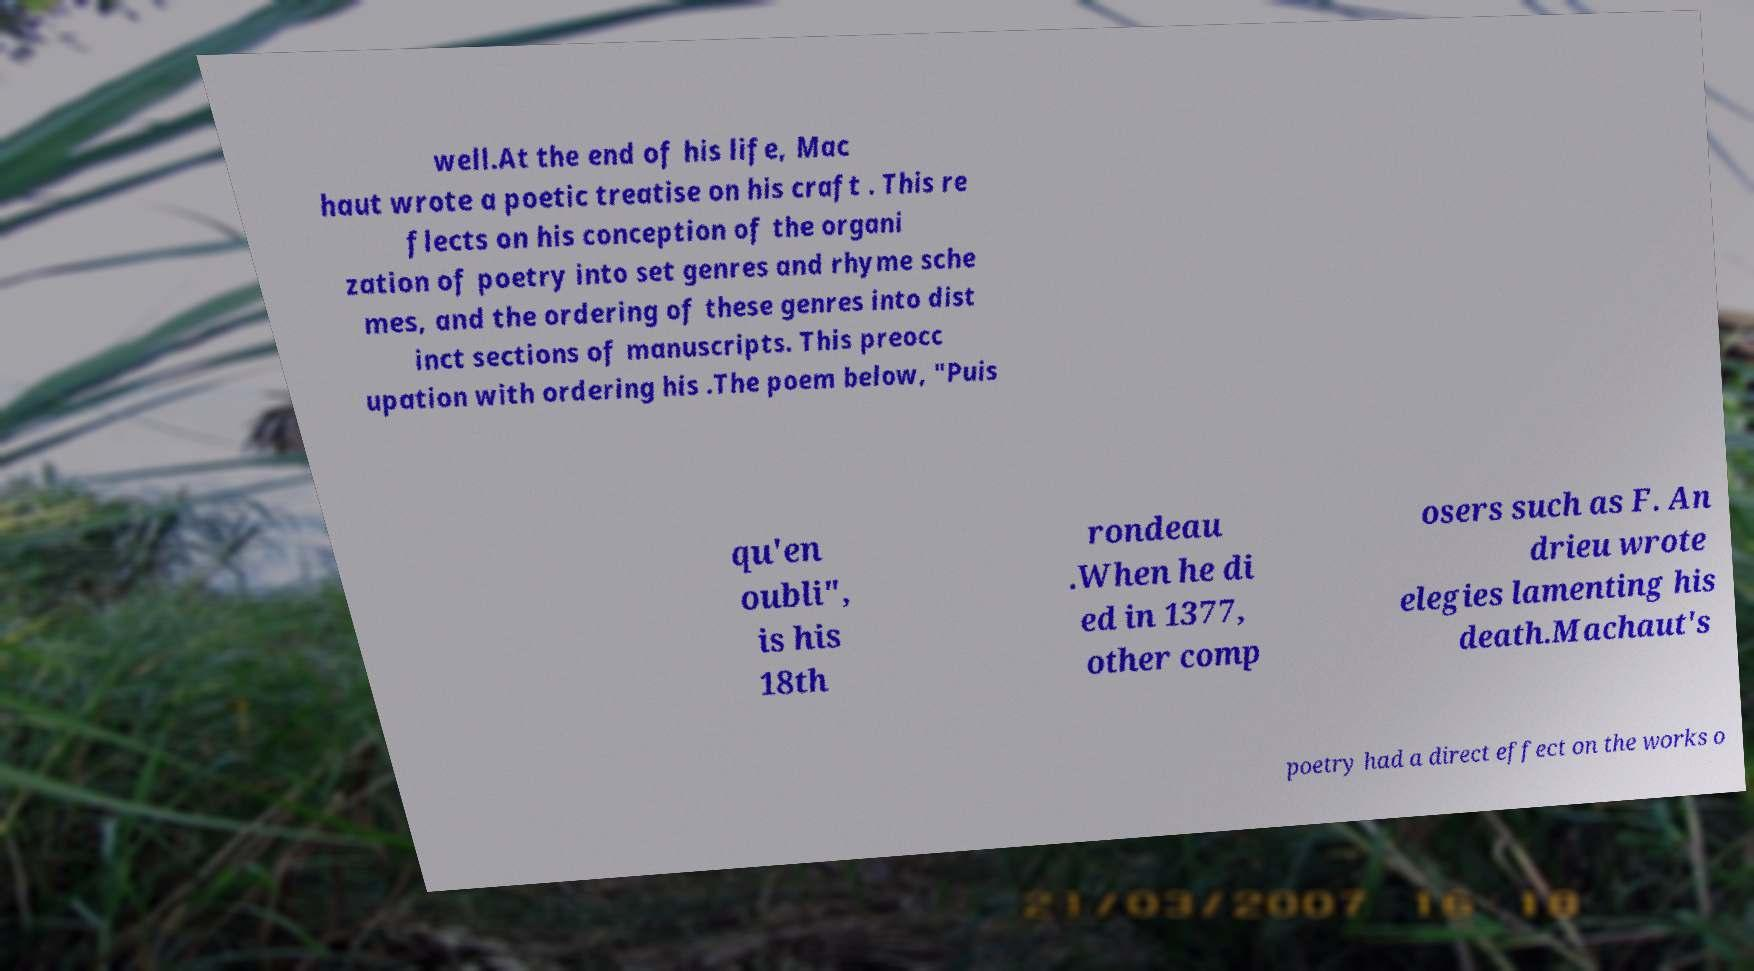Please read and relay the text visible in this image. What does it say? well.At the end of his life, Mac haut wrote a poetic treatise on his craft . This re flects on his conception of the organi zation of poetry into set genres and rhyme sche mes, and the ordering of these genres into dist inct sections of manuscripts. This preocc upation with ordering his .The poem below, "Puis qu'en oubli", is his 18th rondeau .When he di ed in 1377, other comp osers such as F. An drieu wrote elegies lamenting his death.Machaut's poetry had a direct effect on the works o 